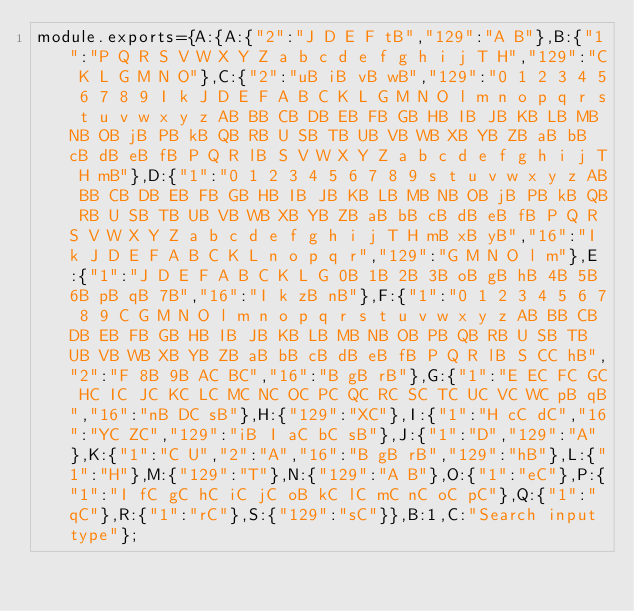<code> <loc_0><loc_0><loc_500><loc_500><_JavaScript_>module.exports={A:{A:{"2":"J D E F tB","129":"A B"},B:{"1":"P Q R S V W X Y Z a b c d e f g h i j T H","129":"C K L G M N O"},C:{"2":"uB iB vB wB","129":"0 1 2 3 4 5 6 7 8 9 I k J D E F A B C K L G M N O l m n o p q r s t u v w x y z AB BB CB DB EB FB GB HB IB JB KB LB MB NB OB jB PB kB QB RB U SB TB UB VB WB XB YB ZB aB bB cB dB eB fB P Q R lB S V W X Y Z a b c d e f g h i j T H mB"},D:{"1":"0 1 2 3 4 5 6 7 8 9 s t u v w x y z AB BB CB DB EB FB GB HB IB JB KB LB MB NB OB jB PB kB QB RB U SB TB UB VB WB XB YB ZB aB bB cB dB eB fB P Q R S V W X Y Z a b c d e f g h i j T H mB xB yB","16":"I k J D E F A B C K L n o p q r","129":"G M N O l m"},E:{"1":"J D E F A B C K L G 0B 1B 2B 3B oB gB hB 4B 5B 6B pB qB 7B","16":"I k zB nB"},F:{"1":"0 1 2 3 4 5 6 7 8 9 C G M N O l m n o p q r s t u v w x y z AB BB CB DB EB FB GB HB IB JB KB LB MB NB OB PB QB RB U SB TB UB VB WB XB YB ZB aB bB cB dB eB fB P Q R lB S CC hB","2":"F 8B 9B AC BC","16":"B gB rB"},G:{"1":"E EC FC GC HC IC JC KC LC MC NC OC PC QC RC SC TC UC VC WC pB qB","16":"nB DC sB"},H:{"129":"XC"},I:{"1":"H cC dC","16":"YC ZC","129":"iB I aC bC sB"},J:{"1":"D","129":"A"},K:{"1":"C U","2":"A","16":"B gB rB","129":"hB"},L:{"1":"H"},M:{"129":"T"},N:{"129":"A B"},O:{"1":"eC"},P:{"1":"I fC gC hC iC jC oB kC lC mC nC oC pC"},Q:{"1":"qC"},R:{"1":"rC"},S:{"129":"sC"}},B:1,C:"Search input type"};
</code> 